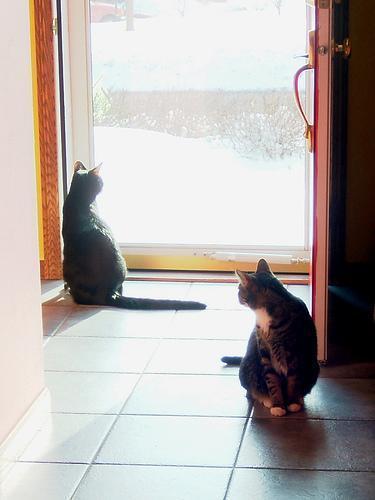How many cats are in the scene?
Give a very brief answer. 2. How many doors are open?
Give a very brief answer. 1. How many floor tiles with any part of a cat on them are in the picture?
Give a very brief answer. 9. 